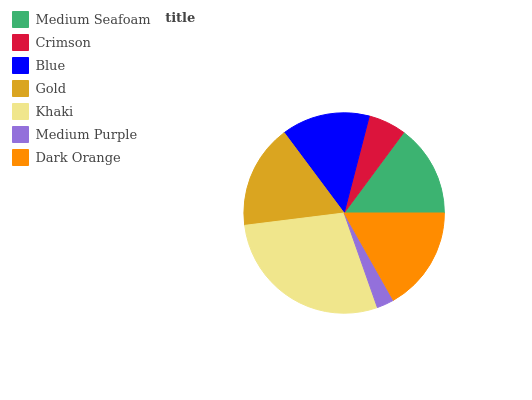Is Medium Purple the minimum?
Answer yes or no. Yes. Is Khaki the maximum?
Answer yes or no. Yes. Is Crimson the minimum?
Answer yes or no. No. Is Crimson the maximum?
Answer yes or no. No. Is Medium Seafoam greater than Crimson?
Answer yes or no. Yes. Is Crimson less than Medium Seafoam?
Answer yes or no. Yes. Is Crimson greater than Medium Seafoam?
Answer yes or no. No. Is Medium Seafoam less than Crimson?
Answer yes or no. No. Is Medium Seafoam the high median?
Answer yes or no. Yes. Is Medium Seafoam the low median?
Answer yes or no. Yes. Is Blue the high median?
Answer yes or no. No. Is Dark Orange the low median?
Answer yes or no. No. 